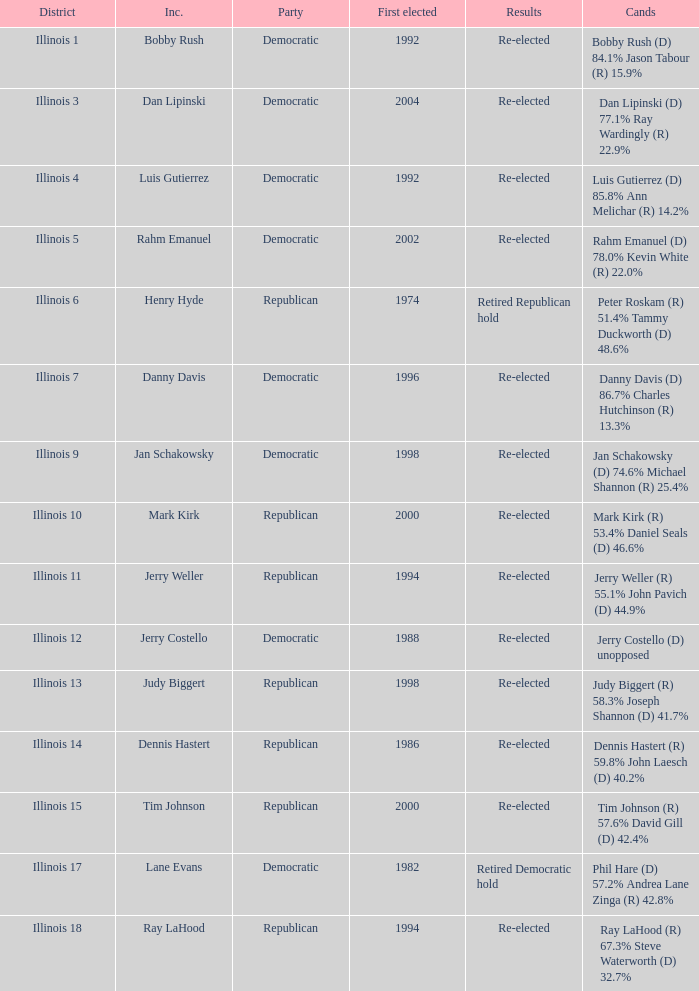What is the district when the first elected was in 1986? Illinois 14. 